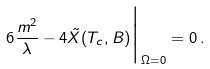<formula> <loc_0><loc_0><loc_500><loc_500>6 \frac { m ^ { 2 } } { \lambda } - 4 { \tilde { X } } ( T _ { c } , B ) \Big | _ { \Omega = 0 } = 0 \, .</formula> 